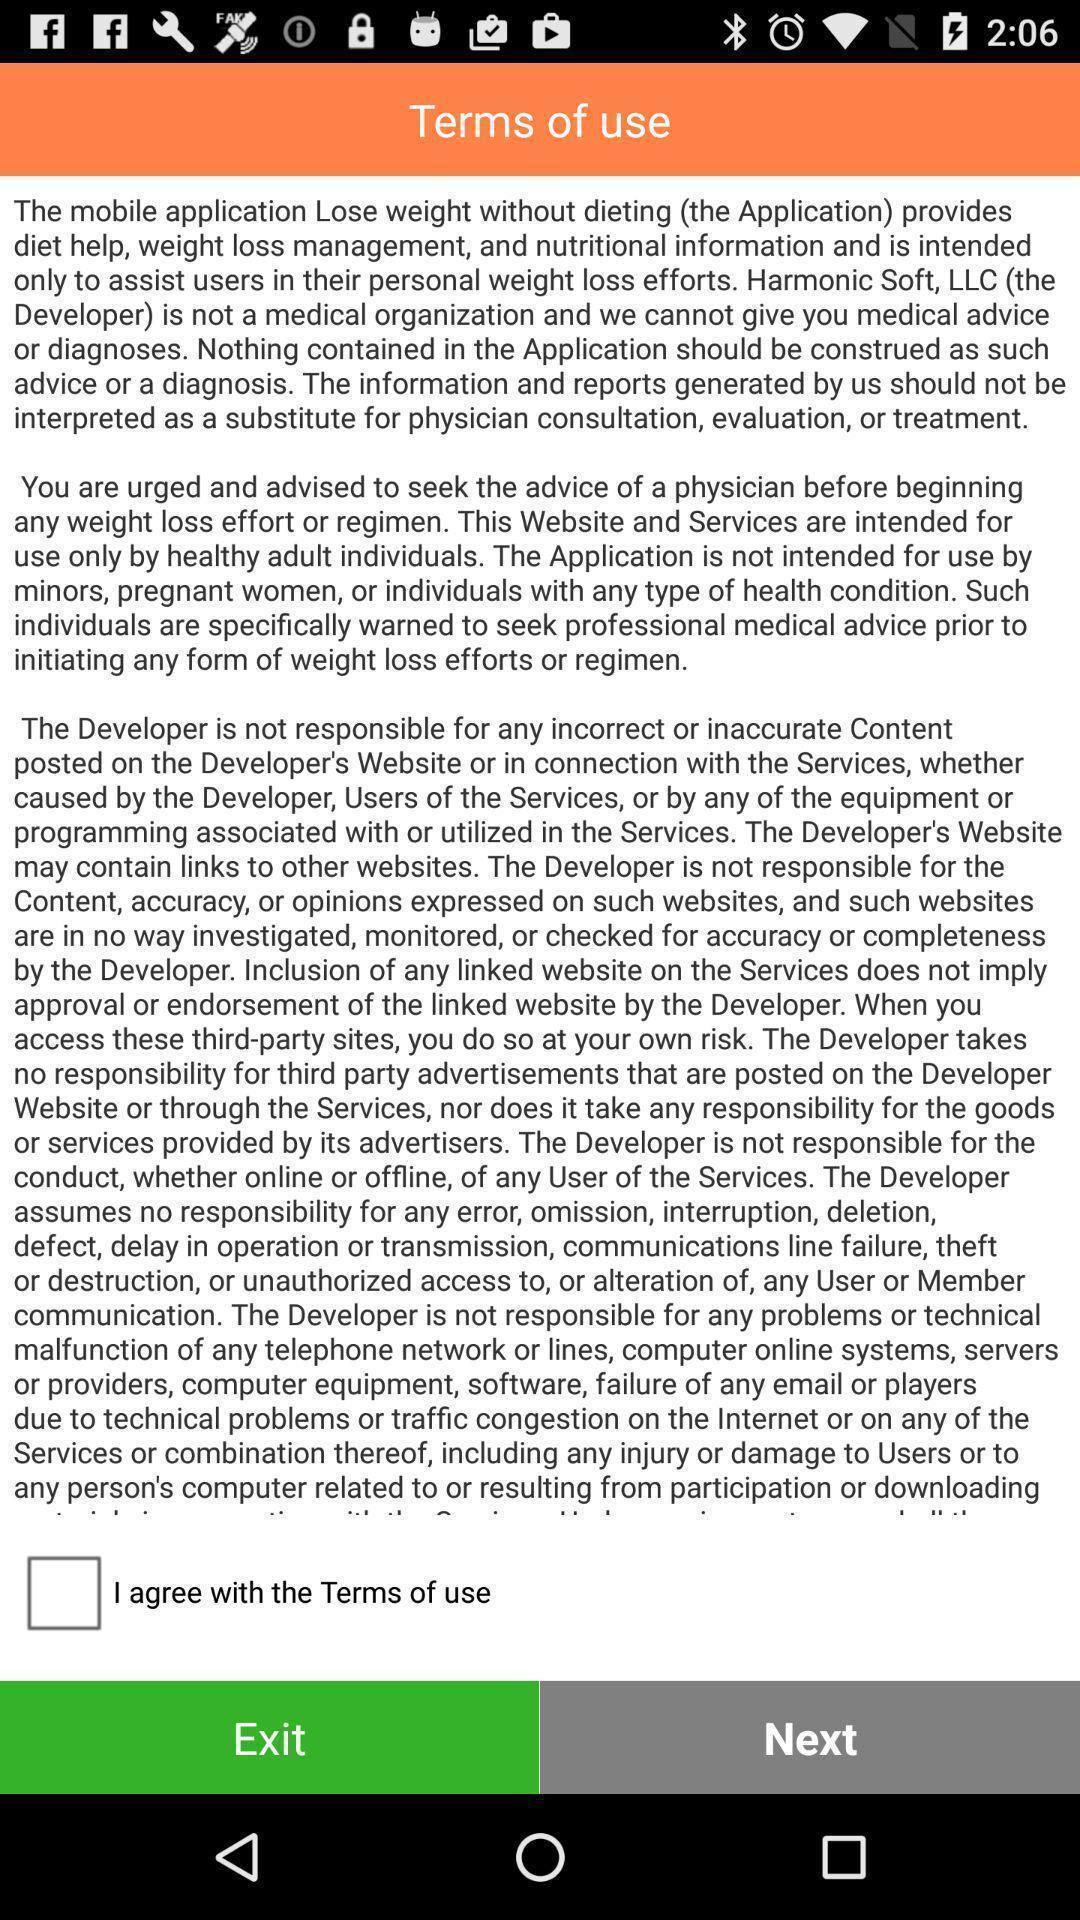Explain the elements present in this screenshot. Screen displaying terms of use. 